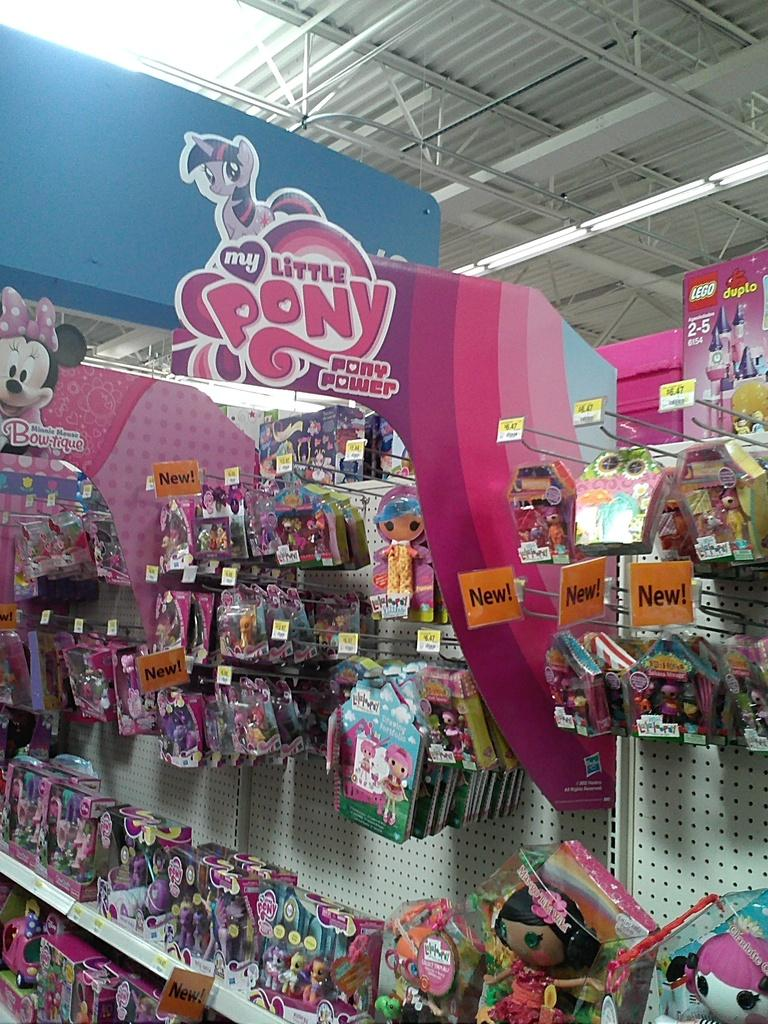<image>
Render a clear and concise summary of the photo. An aisle in a store that sells My Little Pony toys 